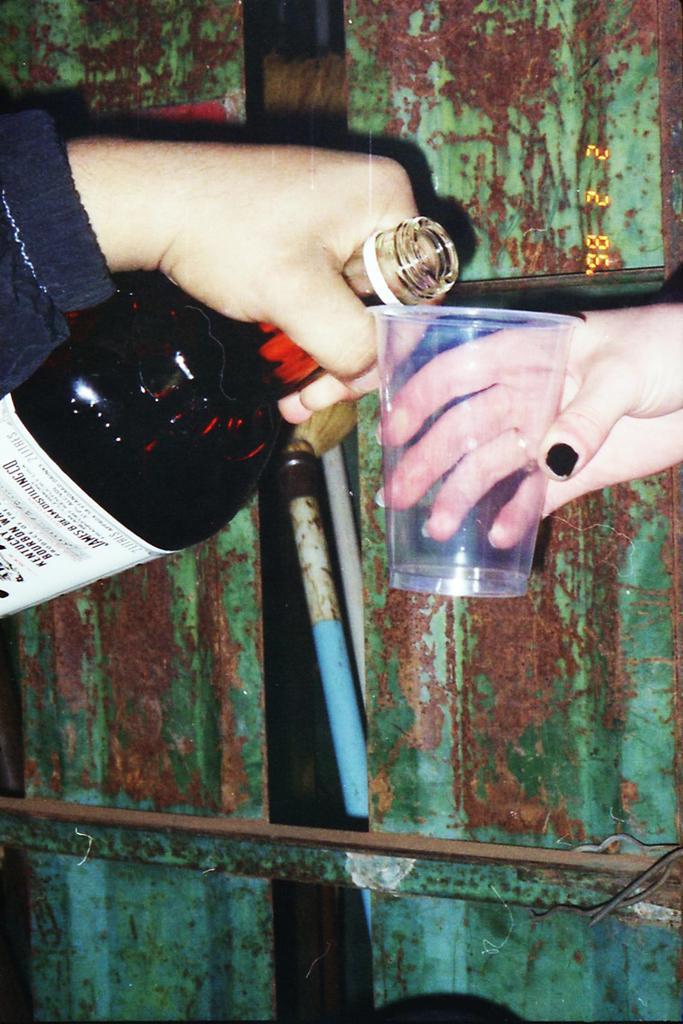Can you describe this image briefly? To the right side there is a hand holding a glass. And to the left side there is a person holding a bottle in their hand. In the background there are iron object. 